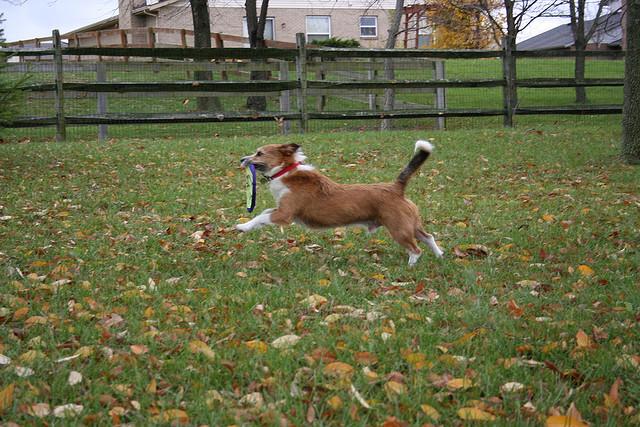What is the dog carrying in its mouth?
Concise answer only. Frisbee. Which animal is in the photo?
Write a very short answer. Dog. What color is the dog's collar?
Short answer required. Red. What kind of dog is that?
Be succinct. Collie. 